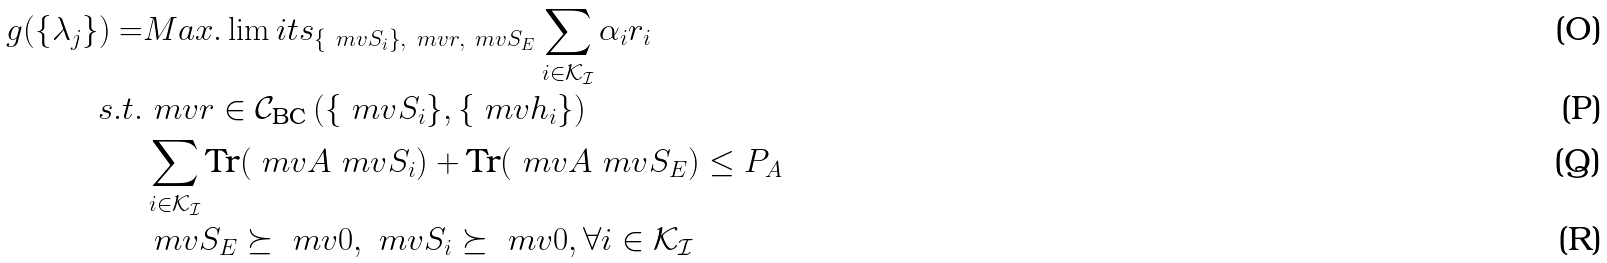<formula> <loc_0><loc_0><loc_500><loc_500>g ( \{ \lambda _ { j } \} ) = & M a x . \lim i t s _ { \left \{ \ m v { S } _ { i } \right \} , \ m v { r } , \ m v { S } _ { E } } \sum _ { i \in \mathcal { K _ { I } } } \alpha _ { i } r _ { i } \\ s . t . & \ m v { r } \in \mathcal { C } _ { \text {BC} } \left ( \{ \ m v { S } _ { i } \} , \{ \ m v { h } _ { i } \} \right ) \\ & \sum _ { i \in \mathcal { K _ { I } } } \text {Tr} ( \ m v { A } \ m v { S } _ { i } ) + \text {Tr} ( \ m v { A } \ m v { S } _ { E } ) \leq P _ { A } \\ & \ m v { S } _ { E } \succeq \ m v { 0 } , \ m v { S } _ { i } \succeq \ m v { 0 } , \forall i \in \mathcal { K _ { I } }</formula> 